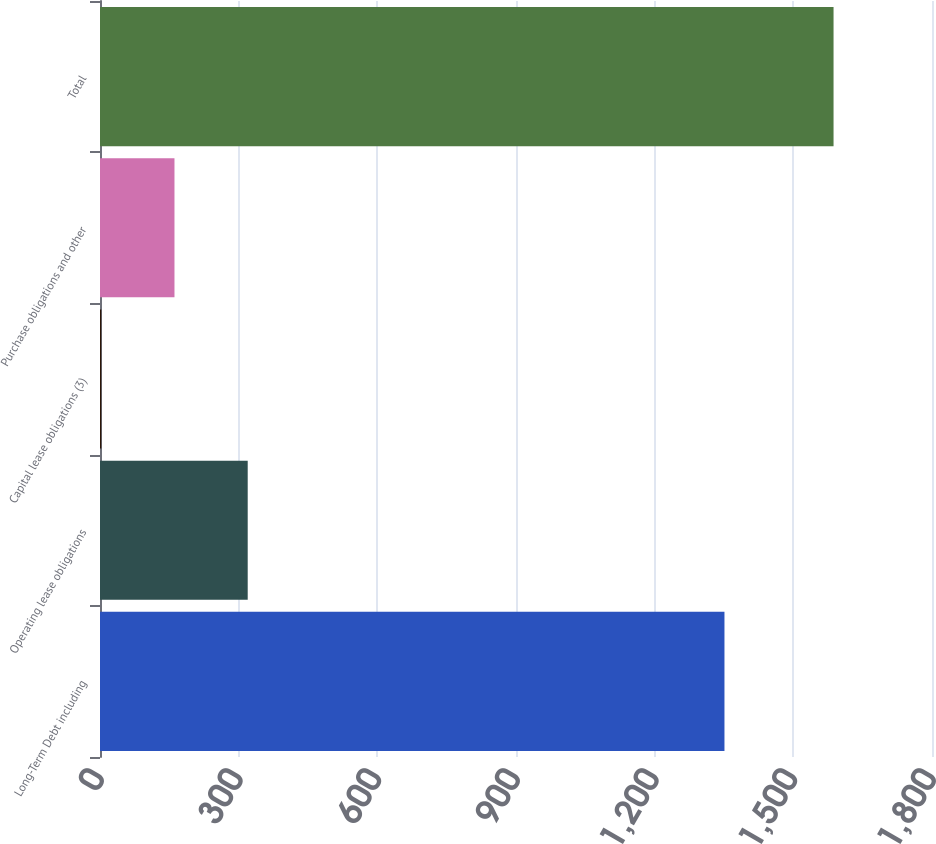<chart> <loc_0><loc_0><loc_500><loc_500><bar_chart><fcel>Long-Term Debt including<fcel>Operating lease obligations<fcel>Capital lease obligations (3)<fcel>Purchase obligations and other<fcel>Total<nl><fcel>1351<fcel>319.56<fcel>2.7<fcel>161.13<fcel>1587<nl></chart> 